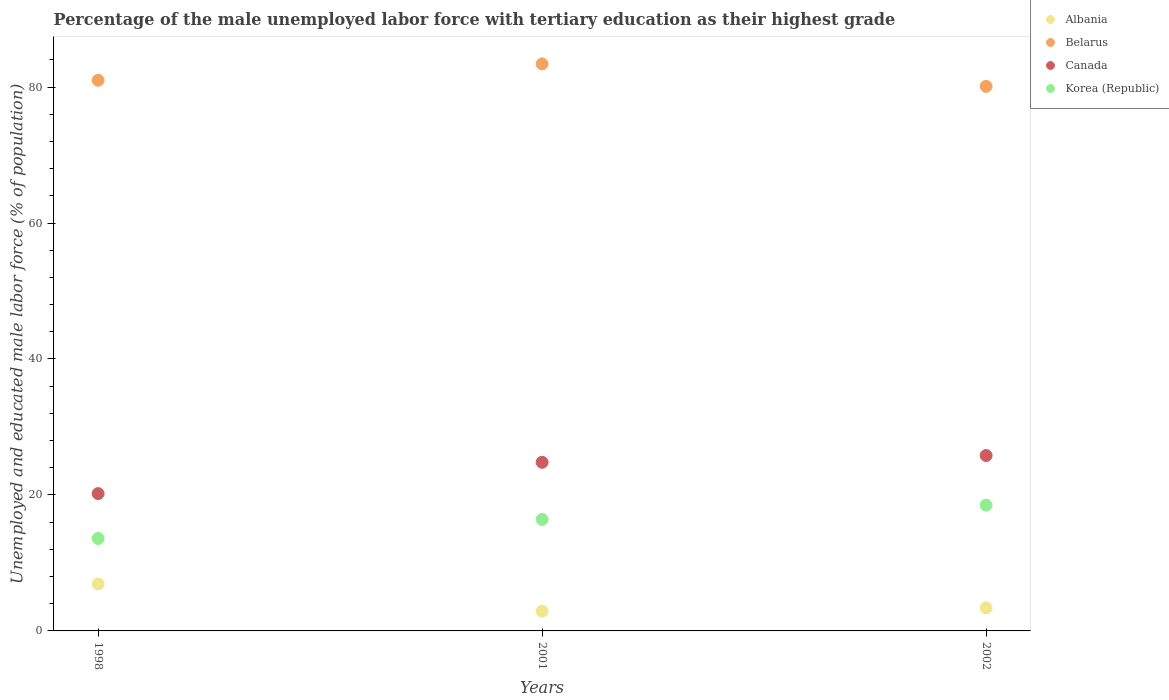How many different coloured dotlines are there?
Give a very brief answer. 4. Is the number of dotlines equal to the number of legend labels?
Your response must be concise. Yes. Across all years, what is the minimum percentage of the unemployed male labor force with tertiary education in Albania?
Ensure brevity in your answer.  2.9. What is the total percentage of the unemployed male labor force with tertiary education in Canada in the graph?
Your response must be concise. 70.8. What is the difference between the percentage of the unemployed male labor force with tertiary education in Canada in 1998 and that in 2002?
Keep it short and to the point. -5.6. What is the difference between the percentage of the unemployed male labor force with tertiary education in Albania in 1998 and the percentage of the unemployed male labor force with tertiary education in Canada in 2002?
Offer a terse response. -18.9. What is the average percentage of the unemployed male labor force with tertiary education in Albania per year?
Make the answer very short. 4.4. In the year 2002, what is the difference between the percentage of the unemployed male labor force with tertiary education in Canada and percentage of the unemployed male labor force with tertiary education in Belarus?
Keep it short and to the point. -54.3. In how many years, is the percentage of the unemployed male labor force with tertiary education in Canada greater than 68 %?
Your response must be concise. 0. What is the ratio of the percentage of the unemployed male labor force with tertiary education in Belarus in 1998 to that in 2001?
Give a very brief answer. 0.97. What is the difference between the highest and the second highest percentage of the unemployed male labor force with tertiary education in Belarus?
Provide a succinct answer. 2.4. What is the difference between the highest and the lowest percentage of the unemployed male labor force with tertiary education in Canada?
Make the answer very short. 5.6. In how many years, is the percentage of the unemployed male labor force with tertiary education in Korea (Republic) greater than the average percentage of the unemployed male labor force with tertiary education in Korea (Republic) taken over all years?
Offer a very short reply. 2. Is the sum of the percentage of the unemployed male labor force with tertiary education in Canada in 1998 and 2001 greater than the maximum percentage of the unemployed male labor force with tertiary education in Korea (Republic) across all years?
Your answer should be compact. Yes. Is it the case that in every year, the sum of the percentage of the unemployed male labor force with tertiary education in Canada and percentage of the unemployed male labor force with tertiary education in Belarus  is greater than the sum of percentage of the unemployed male labor force with tertiary education in Albania and percentage of the unemployed male labor force with tertiary education in Korea (Republic)?
Your answer should be very brief. No. Does the percentage of the unemployed male labor force with tertiary education in Canada monotonically increase over the years?
Ensure brevity in your answer.  Yes. Is the percentage of the unemployed male labor force with tertiary education in Korea (Republic) strictly less than the percentage of the unemployed male labor force with tertiary education in Albania over the years?
Offer a very short reply. No. How many years are there in the graph?
Your answer should be very brief. 3. Are the values on the major ticks of Y-axis written in scientific E-notation?
Offer a very short reply. No. Where does the legend appear in the graph?
Provide a succinct answer. Top right. How many legend labels are there?
Your answer should be very brief. 4. How are the legend labels stacked?
Give a very brief answer. Vertical. What is the title of the graph?
Your response must be concise. Percentage of the male unemployed labor force with tertiary education as their highest grade. Does "Least developed countries" appear as one of the legend labels in the graph?
Offer a very short reply. No. What is the label or title of the X-axis?
Give a very brief answer. Years. What is the label or title of the Y-axis?
Make the answer very short. Unemployed and educated male labor force (% of population). What is the Unemployed and educated male labor force (% of population) in Albania in 1998?
Provide a short and direct response. 6.9. What is the Unemployed and educated male labor force (% of population) of Canada in 1998?
Ensure brevity in your answer.  20.2. What is the Unemployed and educated male labor force (% of population) of Korea (Republic) in 1998?
Your answer should be very brief. 13.6. What is the Unemployed and educated male labor force (% of population) of Albania in 2001?
Offer a terse response. 2.9. What is the Unemployed and educated male labor force (% of population) in Belarus in 2001?
Keep it short and to the point. 83.4. What is the Unemployed and educated male labor force (% of population) of Canada in 2001?
Offer a terse response. 24.8. What is the Unemployed and educated male labor force (% of population) in Korea (Republic) in 2001?
Your answer should be compact. 16.4. What is the Unemployed and educated male labor force (% of population) in Albania in 2002?
Make the answer very short. 3.4. What is the Unemployed and educated male labor force (% of population) of Belarus in 2002?
Your answer should be compact. 80.1. What is the Unemployed and educated male labor force (% of population) in Canada in 2002?
Ensure brevity in your answer.  25.8. Across all years, what is the maximum Unemployed and educated male labor force (% of population) in Albania?
Offer a terse response. 6.9. Across all years, what is the maximum Unemployed and educated male labor force (% of population) of Belarus?
Make the answer very short. 83.4. Across all years, what is the maximum Unemployed and educated male labor force (% of population) in Canada?
Ensure brevity in your answer.  25.8. Across all years, what is the minimum Unemployed and educated male labor force (% of population) of Albania?
Offer a terse response. 2.9. Across all years, what is the minimum Unemployed and educated male labor force (% of population) of Belarus?
Keep it short and to the point. 80.1. Across all years, what is the minimum Unemployed and educated male labor force (% of population) of Canada?
Your answer should be very brief. 20.2. Across all years, what is the minimum Unemployed and educated male labor force (% of population) in Korea (Republic)?
Keep it short and to the point. 13.6. What is the total Unemployed and educated male labor force (% of population) in Albania in the graph?
Provide a succinct answer. 13.2. What is the total Unemployed and educated male labor force (% of population) of Belarus in the graph?
Make the answer very short. 244.5. What is the total Unemployed and educated male labor force (% of population) in Canada in the graph?
Your answer should be very brief. 70.8. What is the total Unemployed and educated male labor force (% of population) in Korea (Republic) in the graph?
Your answer should be compact. 48.5. What is the difference between the Unemployed and educated male labor force (% of population) in Canada in 1998 and that in 2001?
Give a very brief answer. -4.6. What is the difference between the Unemployed and educated male labor force (% of population) in Korea (Republic) in 1998 and that in 2001?
Provide a succinct answer. -2.8. What is the difference between the Unemployed and educated male labor force (% of population) of Albania in 1998 and that in 2002?
Give a very brief answer. 3.5. What is the difference between the Unemployed and educated male labor force (% of population) in Belarus in 1998 and that in 2002?
Your response must be concise. 0.9. What is the difference between the Unemployed and educated male labor force (% of population) of Canada in 1998 and that in 2002?
Provide a short and direct response. -5.6. What is the difference between the Unemployed and educated male labor force (% of population) in Albania in 2001 and that in 2002?
Your answer should be very brief. -0.5. What is the difference between the Unemployed and educated male labor force (% of population) in Belarus in 2001 and that in 2002?
Provide a short and direct response. 3.3. What is the difference between the Unemployed and educated male labor force (% of population) in Canada in 2001 and that in 2002?
Your answer should be compact. -1. What is the difference between the Unemployed and educated male labor force (% of population) in Korea (Republic) in 2001 and that in 2002?
Give a very brief answer. -2.1. What is the difference between the Unemployed and educated male labor force (% of population) in Albania in 1998 and the Unemployed and educated male labor force (% of population) in Belarus in 2001?
Provide a short and direct response. -76.5. What is the difference between the Unemployed and educated male labor force (% of population) in Albania in 1998 and the Unemployed and educated male labor force (% of population) in Canada in 2001?
Your response must be concise. -17.9. What is the difference between the Unemployed and educated male labor force (% of population) in Belarus in 1998 and the Unemployed and educated male labor force (% of population) in Canada in 2001?
Make the answer very short. 56.2. What is the difference between the Unemployed and educated male labor force (% of population) in Belarus in 1998 and the Unemployed and educated male labor force (% of population) in Korea (Republic) in 2001?
Ensure brevity in your answer.  64.6. What is the difference between the Unemployed and educated male labor force (% of population) of Canada in 1998 and the Unemployed and educated male labor force (% of population) of Korea (Republic) in 2001?
Provide a short and direct response. 3.8. What is the difference between the Unemployed and educated male labor force (% of population) in Albania in 1998 and the Unemployed and educated male labor force (% of population) in Belarus in 2002?
Ensure brevity in your answer.  -73.2. What is the difference between the Unemployed and educated male labor force (% of population) of Albania in 1998 and the Unemployed and educated male labor force (% of population) of Canada in 2002?
Provide a short and direct response. -18.9. What is the difference between the Unemployed and educated male labor force (% of population) of Belarus in 1998 and the Unemployed and educated male labor force (% of population) of Canada in 2002?
Your response must be concise. 55.2. What is the difference between the Unemployed and educated male labor force (% of population) in Belarus in 1998 and the Unemployed and educated male labor force (% of population) in Korea (Republic) in 2002?
Offer a terse response. 62.5. What is the difference between the Unemployed and educated male labor force (% of population) in Canada in 1998 and the Unemployed and educated male labor force (% of population) in Korea (Republic) in 2002?
Provide a succinct answer. 1.7. What is the difference between the Unemployed and educated male labor force (% of population) in Albania in 2001 and the Unemployed and educated male labor force (% of population) in Belarus in 2002?
Ensure brevity in your answer.  -77.2. What is the difference between the Unemployed and educated male labor force (% of population) of Albania in 2001 and the Unemployed and educated male labor force (% of population) of Canada in 2002?
Offer a terse response. -22.9. What is the difference between the Unemployed and educated male labor force (% of population) of Albania in 2001 and the Unemployed and educated male labor force (% of population) of Korea (Republic) in 2002?
Offer a very short reply. -15.6. What is the difference between the Unemployed and educated male labor force (% of population) of Belarus in 2001 and the Unemployed and educated male labor force (% of population) of Canada in 2002?
Provide a succinct answer. 57.6. What is the difference between the Unemployed and educated male labor force (% of population) in Belarus in 2001 and the Unemployed and educated male labor force (% of population) in Korea (Republic) in 2002?
Your response must be concise. 64.9. What is the difference between the Unemployed and educated male labor force (% of population) in Canada in 2001 and the Unemployed and educated male labor force (% of population) in Korea (Republic) in 2002?
Your answer should be very brief. 6.3. What is the average Unemployed and educated male labor force (% of population) in Belarus per year?
Give a very brief answer. 81.5. What is the average Unemployed and educated male labor force (% of population) of Canada per year?
Provide a succinct answer. 23.6. What is the average Unemployed and educated male labor force (% of population) in Korea (Republic) per year?
Provide a succinct answer. 16.17. In the year 1998, what is the difference between the Unemployed and educated male labor force (% of population) of Albania and Unemployed and educated male labor force (% of population) of Belarus?
Make the answer very short. -74.1. In the year 1998, what is the difference between the Unemployed and educated male labor force (% of population) in Belarus and Unemployed and educated male labor force (% of population) in Canada?
Provide a short and direct response. 60.8. In the year 1998, what is the difference between the Unemployed and educated male labor force (% of population) of Belarus and Unemployed and educated male labor force (% of population) of Korea (Republic)?
Offer a terse response. 67.4. In the year 1998, what is the difference between the Unemployed and educated male labor force (% of population) in Canada and Unemployed and educated male labor force (% of population) in Korea (Republic)?
Your answer should be very brief. 6.6. In the year 2001, what is the difference between the Unemployed and educated male labor force (% of population) in Albania and Unemployed and educated male labor force (% of population) in Belarus?
Give a very brief answer. -80.5. In the year 2001, what is the difference between the Unemployed and educated male labor force (% of population) in Albania and Unemployed and educated male labor force (% of population) in Canada?
Give a very brief answer. -21.9. In the year 2001, what is the difference between the Unemployed and educated male labor force (% of population) of Albania and Unemployed and educated male labor force (% of population) of Korea (Republic)?
Your answer should be compact. -13.5. In the year 2001, what is the difference between the Unemployed and educated male labor force (% of population) in Belarus and Unemployed and educated male labor force (% of population) in Canada?
Give a very brief answer. 58.6. In the year 2001, what is the difference between the Unemployed and educated male labor force (% of population) of Belarus and Unemployed and educated male labor force (% of population) of Korea (Republic)?
Your answer should be compact. 67. In the year 2002, what is the difference between the Unemployed and educated male labor force (% of population) of Albania and Unemployed and educated male labor force (% of population) of Belarus?
Keep it short and to the point. -76.7. In the year 2002, what is the difference between the Unemployed and educated male labor force (% of population) in Albania and Unemployed and educated male labor force (% of population) in Canada?
Give a very brief answer. -22.4. In the year 2002, what is the difference between the Unemployed and educated male labor force (% of population) of Albania and Unemployed and educated male labor force (% of population) of Korea (Republic)?
Your answer should be compact. -15.1. In the year 2002, what is the difference between the Unemployed and educated male labor force (% of population) of Belarus and Unemployed and educated male labor force (% of population) of Canada?
Make the answer very short. 54.3. In the year 2002, what is the difference between the Unemployed and educated male labor force (% of population) of Belarus and Unemployed and educated male labor force (% of population) of Korea (Republic)?
Provide a succinct answer. 61.6. What is the ratio of the Unemployed and educated male labor force (% of population) of Albania in 1998 to that in 2001?
Ensure brevity in your answer.  2.38. What is the ratio of the Unemployed and educated male labor force (% of population) in Belarus in 1998 to that in 2001?
Keep it short and to the point. 0.97. What is the ratio of the Unemployed and educated male labor force (% of population) in Canada in 1998 to that in 2001?
Keep it short and to the point. 0.81. What is the ratio of the Unemployed and educated male labor force (% of population) in Korea (Republic) in 1998 to that in 2001?
Keep it short and to the point. 0.83. What is the ratio of the Unemployed and educated male labor force (% of population) in Albania in 1998 to that in 2002?
Offer a very short reply. 2.03. What is the ratio of the Unemployed and educated male labor force (% of population) of Belarus in 1998 to that in 2002?
Keep it short and to the point. 1.01. What is the ratio of the Unemployed and educated male labor force (% of population) of Canada in 1998 to that in 2002?
Your answer should be compact. 0.78. What is the ratio of the Unemployed and educated male labor force (% of population) of Korea (Republic) in 1998 to that in 2002?
Provide a short and direct response. 0.74. What is the ratio of the Unemployed and educated male labor force (% of population) in Albania in 2001 to that in 2002?
Your answer should be very brief. 0.85. What is the ratio of the Unemployed and educated male labor force (% of population) of Belarus in 2001 to that in 2002?
Keep it short and to the point. 1.04. What is the ratio of the Unemployed and educated male labor force (% of population) of Canada in 2001 to that in 2002?
Your response must be concise. 0.96. What is the ratio of the Unemployed and educated male labor force (% of population) in Korea (Republic) in 2001 to that in 2002?
Make the answer very short. 0.89. What is the difference between the highest and the second highest Unemployed and educated male labor force (% of population) of Belarus?
Keep it short and to the point. 2.4. What is the difference between the highest and the second highest Unemployed and educated male labor force (% of population) in Canada?
Provide a short and direct response. 1. What is the difference between the highest and the second highest Unemployed and educated male labor force (% of population) in Korea (Republic)?
Give a very brief answer. 2.1. What is the difference between the highest and the lowest Unemployed and educated male labor force (% of population) in Belarus?
Make the answer very short. 3.3. What is the difference between the highest and the lowest Unemployed and educated male labor force (% of population) in Korea (Republic)?
Your response must be concise. 4.9. 